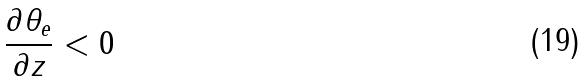Convert formula to latex. <formula><loc_0><loc_0><loc_500><loc_500>\frac { \partial \theta _ { e } } { \partial z } < 0</formula> 